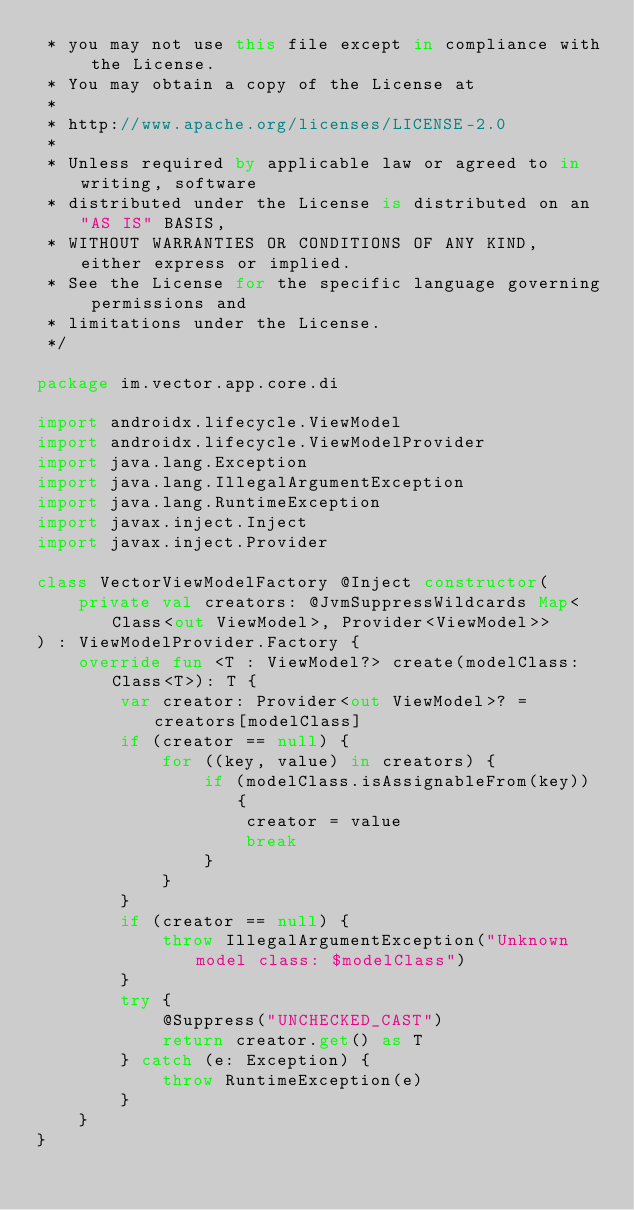<code> <loc_0><loc_0><loc_500><loc_500><_Kotlin_> * you may not use this file except in compliance with the License.
 * You may obtain a copy of the License at
 *
 * http://www.apache.org/licenses/LICENSE-2.0
 *
 * Unless required by applicable law or agreed to in writing, software
 * distributed under the License is distributed on an "AS IS" BASIS,
 * WITHOUT WARRANTIES OR CONDITIONS OF ANY KIND, either express or implied.
 * See the License for the specific language governing permissions and
 * limitations under the License.
 */

package im.vector.app.core.di

import androidx.lifecycle.ViewModel
import androidx.lifecycle.ViewModelProvider
import java.lang.Exception
import java.lang.IllegalArgumentException
import java.lang.RuntimeException
import javax.inject.Inject
import javax.inject.Provider

class VectorViewModelFactory @Inject constructor(
    private val creators: @JvmSuppressWildcards Map<Class<out ViewModel>, Provider<ViewModel>>
) : ViewModelProvider.Factory {
    override fun <T : ViewModel?> create(modelClass: Class<T>): T {
        var creator: Provider<out ViewModel>? = creators[modelClass]
        if (creator == null) {
            for ((key, value) in creators) {
                if (modelClass.isAssignableFrom(key)) {
                    creator = value
                    break
                }
            }
        }
        if (creator == null) {
            throw IllegalArgumentException("Unknown model class: $modelClass")
        }
        try {
            @Suppress("UNCHECKED_CAST")
            return creator.get() as T
        } catch (e: Exception) {
            throw RuntimeException(e)
        }
    }
}</code> 